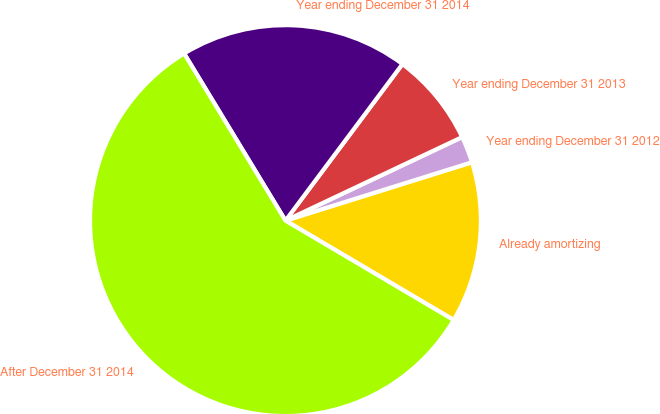Convert chart to OTSL. <chart><loc_0><loc_0><loc_500><loc_500><pie_chart><fcel>Already amortizing<fcel>Year ending December 31 2012<fcel>Year ending December 31 2013<fcel>Year ending December 31 2014<fcel>After December 31 2014<nl><fcel>13.32%<fcel>2.2%<fcel>7.76%<fcel>18.89%<fcel>57.83%<nl></chart> 